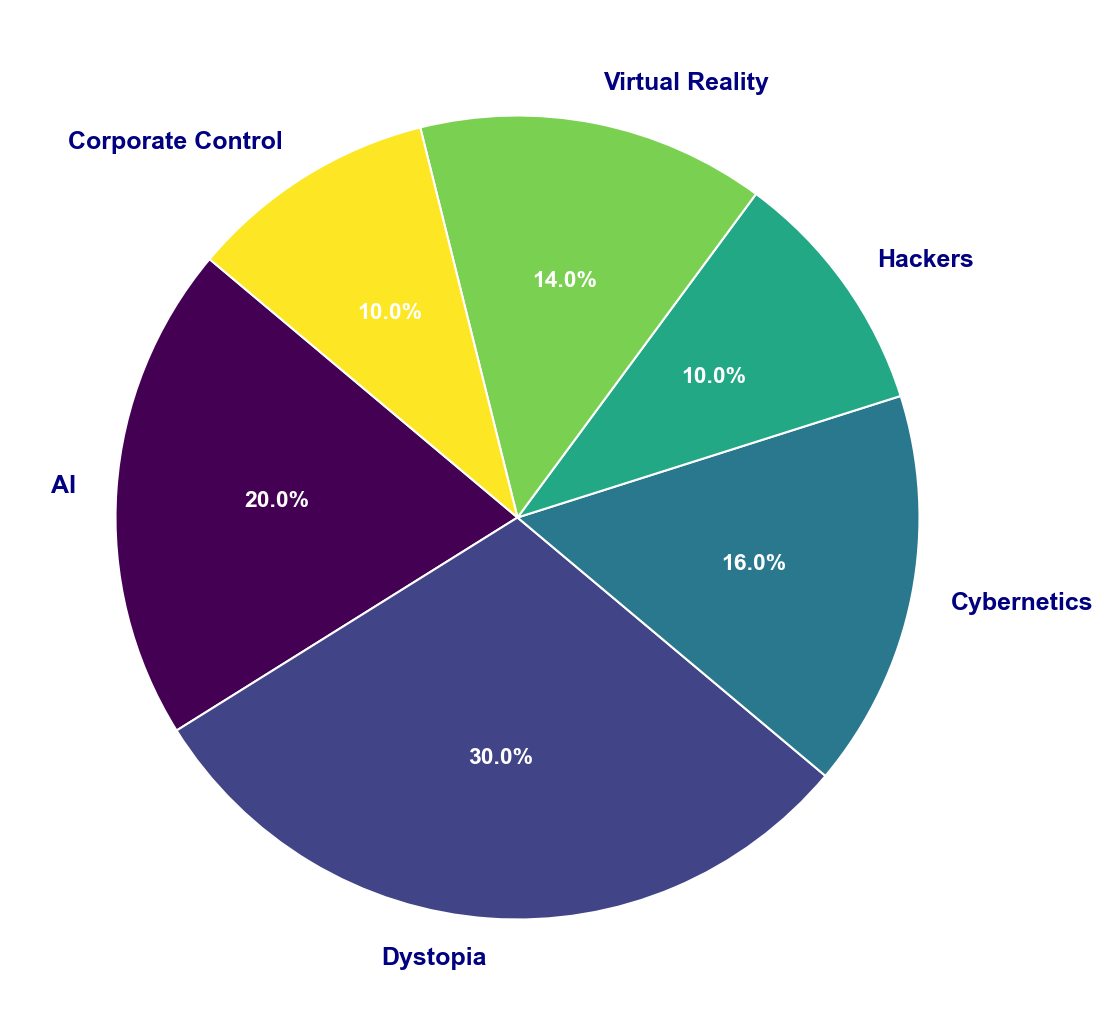What is the most frequently occurring theme in the top 50 cyberpunk novels? The pie chart shows the distribution of themes by percentage. The largest wedge, representing 30.0%, corresponds to the theme Dystopia.
Answer: Dystopia What is the combined percentage of novels with AI and Hackers as themes compared to the total? From the pie chart, AI accounts for 20.0% and Hackers for 10.0%. Adding these gives 20.0% + 10.0% = 30.0%.
Answer: 30.0% Which theme appears more frequently, Cybernetics or Virtual Reality? By comparing the chart wedges, Cybernetics makes up 16.0%, and Virtual Reality makes up 14.0%. Cybernetics has a larger percentage.
Answer: Cybernetics Which two themes have equal representation in the top 50 cyberpunk novels? Corporate Control and Hackers both have wedges accounting for 10.0% of the distribution.
Answer: Corporate Control and Hackers What is the percentage difference between the Dystopia theme and the AI theme? Dystopia accounts for 30.0%, and AI accounts for 20.0%. The difference is 30.0% - 20.0% = 10.0%.
Answer: 10.0% Are there more novels with themes of Corporate Control or Virtual Reality? Virtual Reality accounts for 14.0%, while Corporate Control makes up 10.0%. Virtual Reality has a higher percentage.
Answer: Virtual Reality What percentage of the top 50 cyberpunk novels does the Cybernetics theme cover? The wedge for Cybernetics is marked with 16.0%.
Answer: 16.0% What is the combined representation percentage of the least two frequently occurring themes? The themes Hackers and Corporate Control each account for 10.0%. Combined, this amounts to 10.0% + 10.0% = 20.0%.
Answer: 20.0% If you were to add the percentages of Dystopia, AI, and Cybernetics, what would be the total? Dystopia is 30.0%, AI is 20.0%, and Cybernetics stands at 16.0%. Adding these gives 30.0% + 20.0% + 16.0% = 66.0%.
Answer: 66.0% Is the total percentage of novels with Virtual Reality and Hackers themes greater than that with the Dystopia theme? Virtual Reality accounts for 14.0% and Hackers for 10.0%, totaling 14.0% + 10.0% = 24.0%. Dystopia alone is 30.0%, so 24.0% is less than 30.0%.
Answer: No 